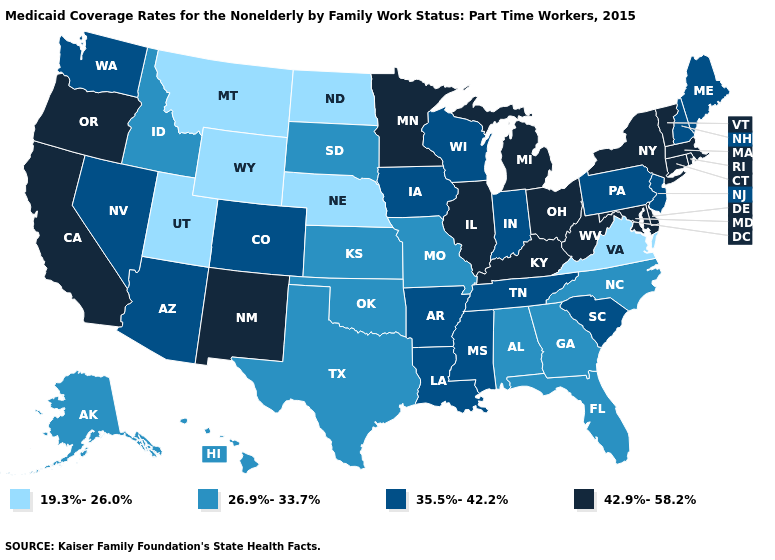Name the states that have a value in the range 35.5%-42.2%?
Keep it brief. Arizona, Arkansas, Colorado, Indiana, Iowa, Louisiana, Maine, Mississippi, Nevada, New Hampshire, New Jersey, Pennsylvania, South Carolina, Tennessee, Washington, Wisconsin. Name the states that have a value in the range 42.9%-58.2%?
Quick response, please. California, Connecticut, Delaware, Illinois, Kentucky, Maryland, Massachusetts, Michigan, Minnesota, New Mexico, New York, Ohio, Oregon, Rhode Island, Vermont, West Virginia. Name the states that have a value in the range 42.9%-58.2%?
Give a very brief answer. California, Connecticut, Delaware, Illinois, Kentucky, Maryland, Massachusetts, Michigan, Minnesota, New Mexico, New York, Ohio, Oregon, Rhode Island, Vermont, West Virginia. What is the value of California?
Quick response, please. 42.9%-58.2%. Does the map have missing data?
Short answer required. No. How many symbols are there in the legend?
Answer briefly. 4. What is the lowest value in states that border Michigan?
Answer briefly. 35.5%-42.2%. Which states have the lowest value in the West?
Give a very brief answer. Montana, Utah, Wyoming. Among the states that border Montana , which have the highest value?
Short answer required. Idaho, South Dakota. Does Montana have the lowest value in the West?
Write a very short answer. Yes. Does Wyoming have the lowest value in the USA?
Answer briefly. Yes. Is the legend a continuous bar?
Be succinct. No. Does New York have a higher value than California?
Quick response, please. No. Does Utah have the lowest value in the USA?
Short answer required. Yes. What is the value of Maryland?
Answer briefly. 42.9%-58.2%. 